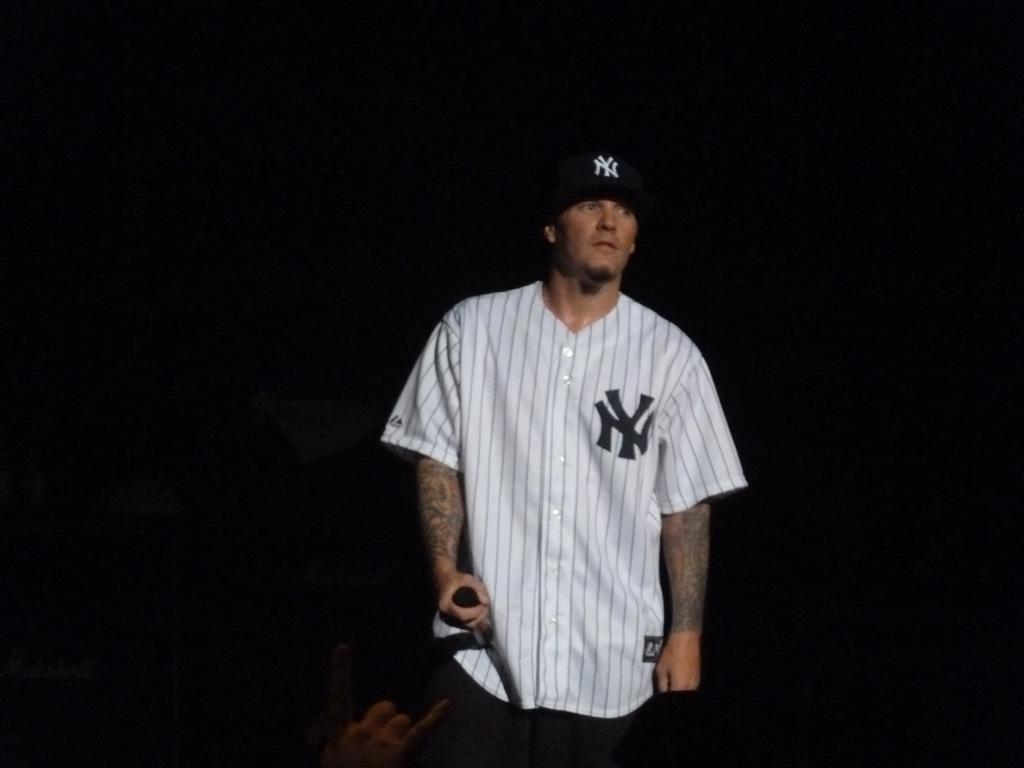Provide a one-sentence caption for the provided image. A man is standing wearing a Yankees cap and shirt. 